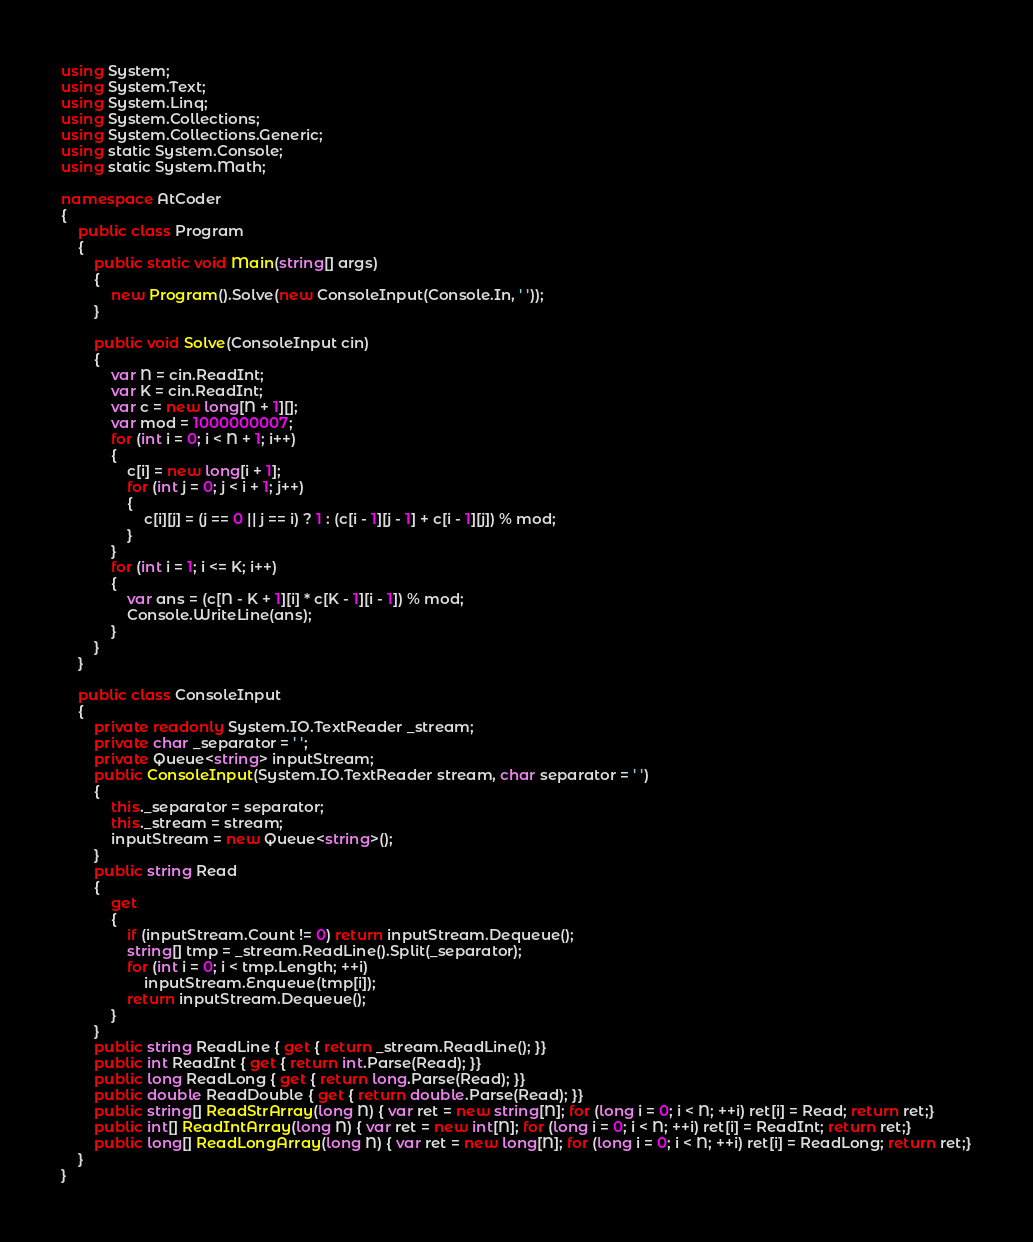Convert code to text. <code><loc_0><loc_0><loc_500><loc_500><_C#_>using System;
using System.Text;
using System.Linq;
using System.Collections;
using System.Collections.Generic;
using static System.Console;
using static System.Math;

namespace AtCoder
{
    public class Program
    {
        public static void Main(string[] args)
        {
            new Program().Solve(new ConsoleInput(Console.In, ' '));
        }

        public void Solve(ConsoleInput cin)
        {
            var N = cin.ReadInt;
            var K = cin.ReadInt;
            var c = new long[N + 1][];
            var mod = 1000000007;
            for (int i = 0; i < N + 1; i++)
            {
                c[i] = new long[i + 1];
                for (int j = 0; j < i + 1; j++)
                {
                    c[i][j] = (j == 0 || j == i) ? 1 : (c[i - 1][j - 1] + c[i - 1][j]) % mod;
                }
            }
            for (int i = 1; i <= K; i++)
            {
                var ans = (c[N - K + 1][i] * c[K - 1][i - 1]) % mod;
                Console.WriteLine(ans);
            }
        }
    }

    public class ConsoleInput
    {
        private readonly System.IO.TextReader _stream;
        private char _separator = ' ';
        private Queue<string> inputStream;
        public ConsoleInput(System.IO.TextReader stream, char separator = ' ')
        {
            this._separator = separator;
            this._stream = stream;
            inputStream = new Queue<string>();
        }
        public string Read
        {
            get
            {
                if (inputStream.Count != 0) return inputStream.Dequeue();
                string[] tmp = _stream.ReadLine().Split(_separator);
                for (int i = 0; i < tmp.Length; ++i)
                    inputStream.Enqueue(tmp[i]);
                return inputStream.Dequeue();
            }
        }
        public string ReadLine { get { return _stream.ReadLine(); }}
        public int ReadInt { get { return int.Parse(Read); }}
        public long ReadLong { get { return long.Parse(Read); }}
        public double ReadDouble { get { return double.Parse(Read); }}
        public string[] ReadStrArray(long N) { var ret = new string[N]; for (long i = 0; i < N; ++i) ret[i] = Read; return ret;}
        public int[] ReadIntArray(long N) { var ret = new int[N]; for (long i = 0; i < N; ++i) ret[i] = ReadInt; return ret;}
        public long[] ReadLongArray(long N) { var ret = new long[N]; for (long i = 0; i < N; ++i) ret[i] = ReadLong; return ret;}
    }
}
</code> 